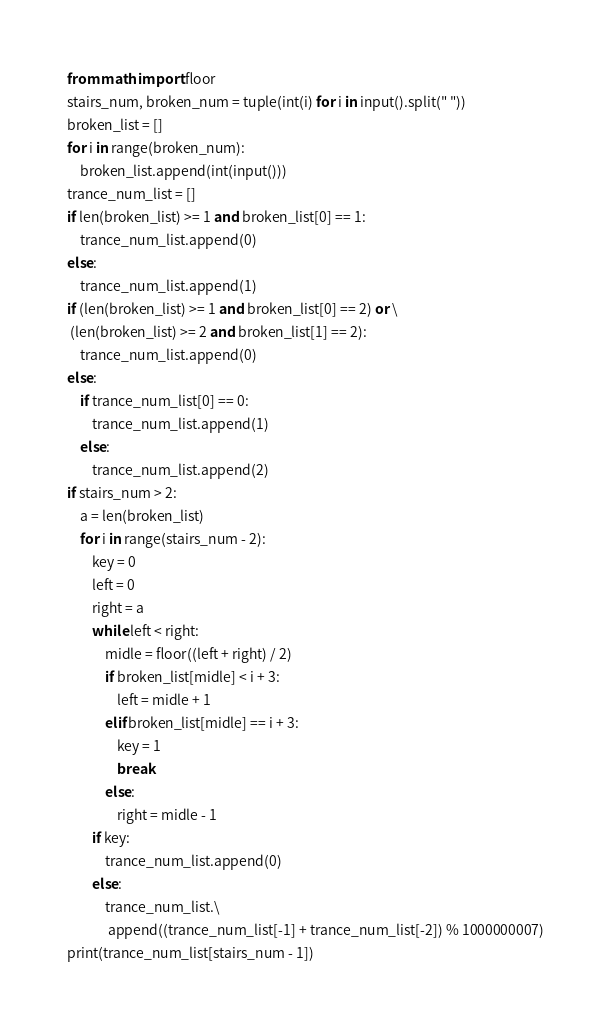Convert code to text. <code><loc_0><loc_0><loc_500><loc_500><_Python_>from math import floor  
stairs_num, broken_num = tuple(int(i) for i in input().split(" "))
broken_list = []
for i in range(broken_num):
    broken_list.append(int(input()))
trance_num_list = []
if len(broken_list) >= 1 and broken_list[0] == 1:
    trance_num_list.append(0)
else:
    trance_num_list.append(1)
if (len(broken_list) >= 1 and broken_list[0] == 2) or \
 (len(broken_list) >= 2 and broken_list[1] == 2):
    trance_num_list.append(0)
else:
    if trance_num_list[0] == 0:
        trance_num_list.append(1)
    else:
        trance_num_list.append(2)
if stairs_num > 2:
    a = len(broken_list)
    for i in range(stairs_num - 2):
        key = 0
        left = 0
        right = a
        while left < right:
            midle = floor((left + right) / 2)
            if broken_list[midle] < i + 3:
                left = midle + 1
            elif broken_list[midle] == i + 3:
                key = 1
                break
            else:
                right = midle - 1
        if key:
            trance_num_list.append(0)
        else:
            trance_num_list.\
             append((trance_num_list[-1] + trance_num_list[-2]) % 1000000007)
print(trance_num_list[stairs_num - 1])</code> 